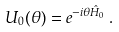Convert formula to latex. <formula><loc_0><loc_0><loc_500><loc_500>U _ { 0 } ( \theta ) = e ^ { - i \theta \hat { H } _ { 0 } } \, .</formula> 